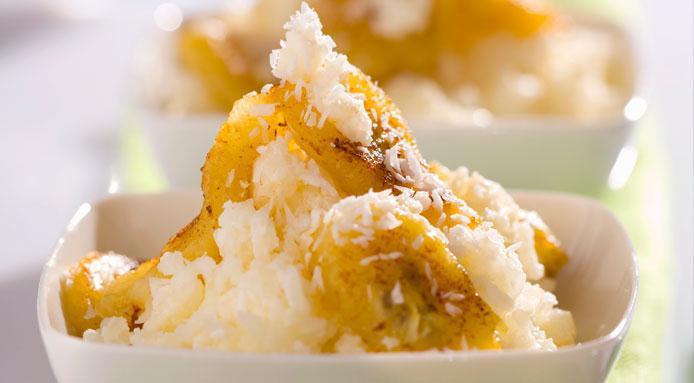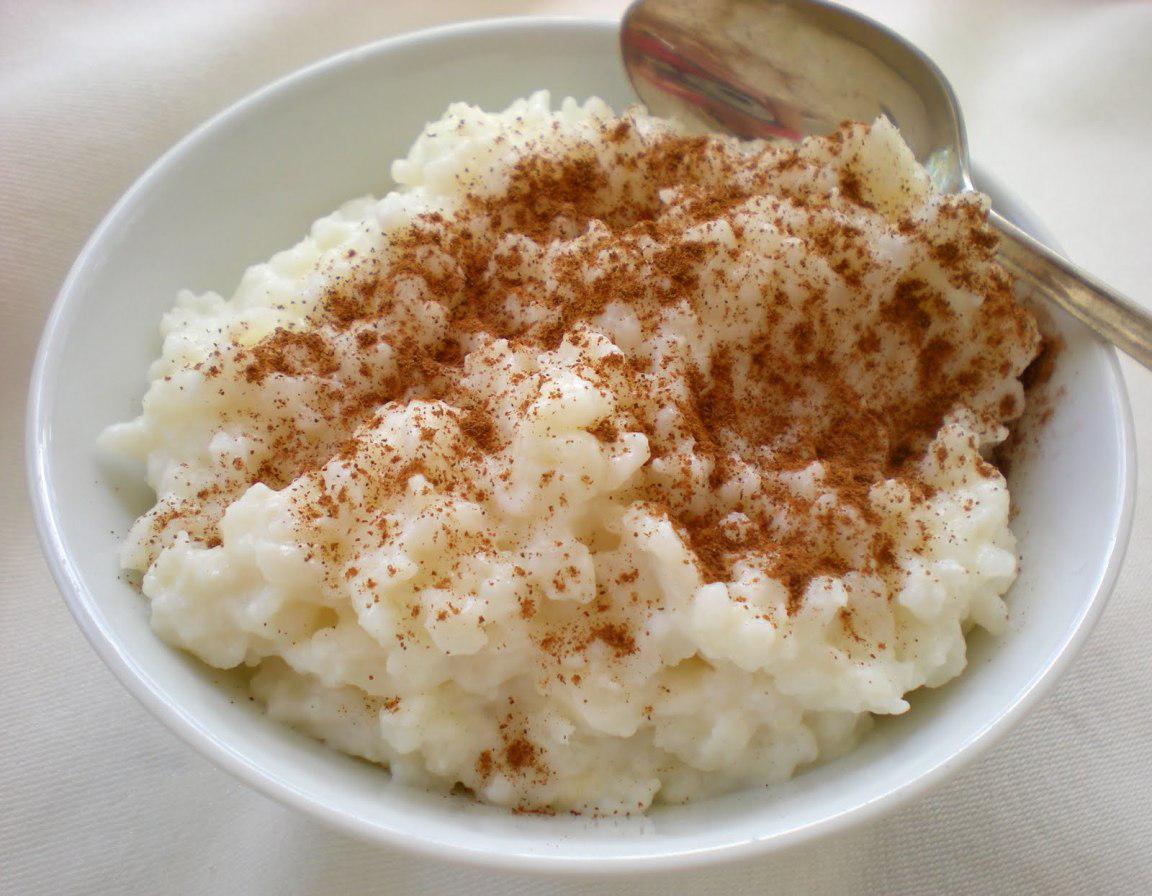The first image is the image on the left, the second image is the image on the right. For the images displayed, is the sentence "All the food items are in bowls." factually correct? Answer yes or no. Yes. The first image is the image on the left, the second image is the image on the right. For the images displayed, is the sentence "An image shows exactly one round bowl that contains something creamy and whitish with brown spice sprinkled on top, and no other ingredients." factually correct? Answer yes or no. Yes. 